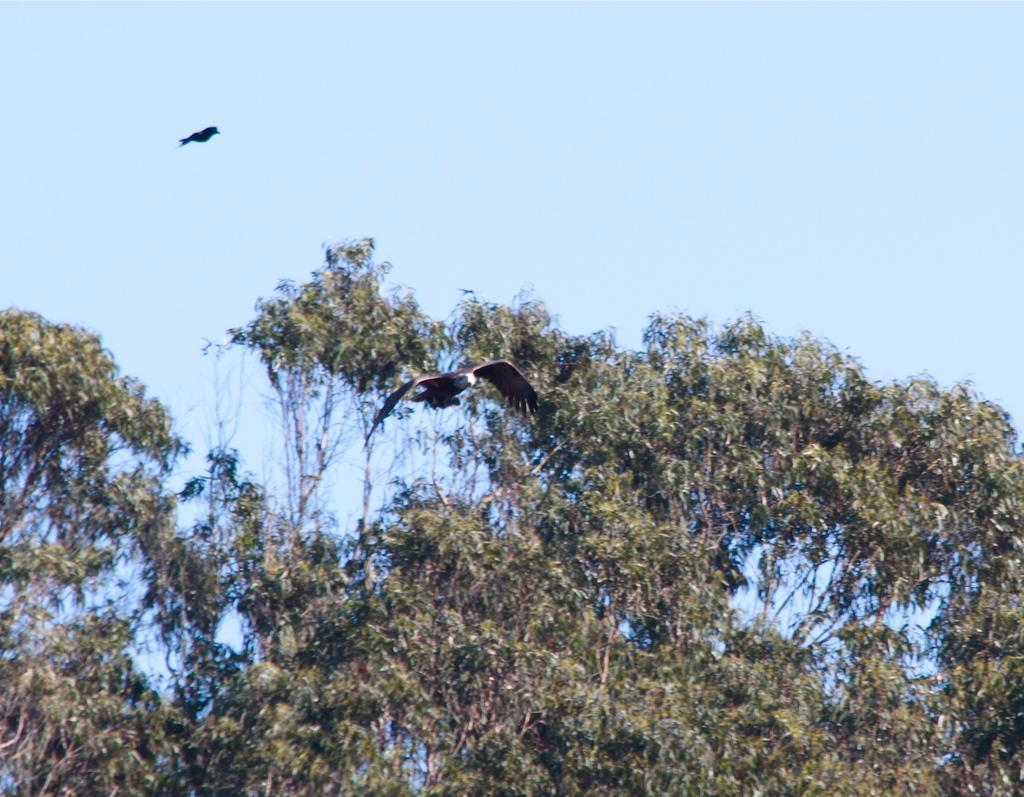What animals are flying in the image? There are two birds flying in the air. What can be seen in the background of the image? There is a tree and the sky visible in the background of the image. Where is the cook standing in the image? There is no cook present in the image. What type of chair can be seen in the image? There is no chair present in the image. 